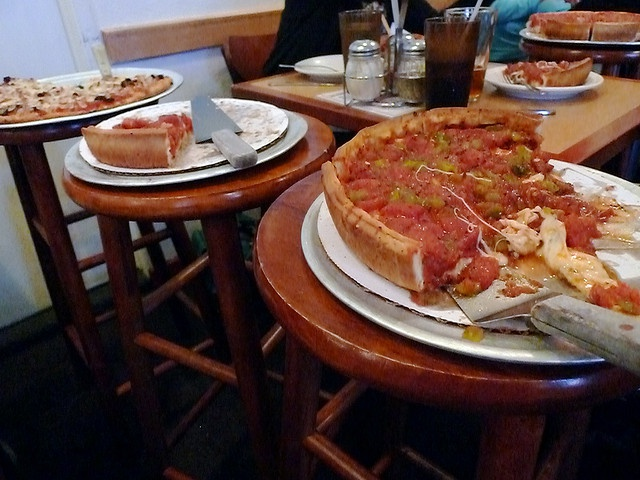Describe the objects in this image and their specific colors. I can see pizza in lavender, brown, red, and maroon tones, dining table in lavender, black, lightgray, darkgray, and tan tones, dining table in lavender, maroon, black, and brown tones, dining table in lavender, tan, gray, maroon, and brown tones, and knife in lavender, darkgray, gray, brown, and tan tones in this image. 